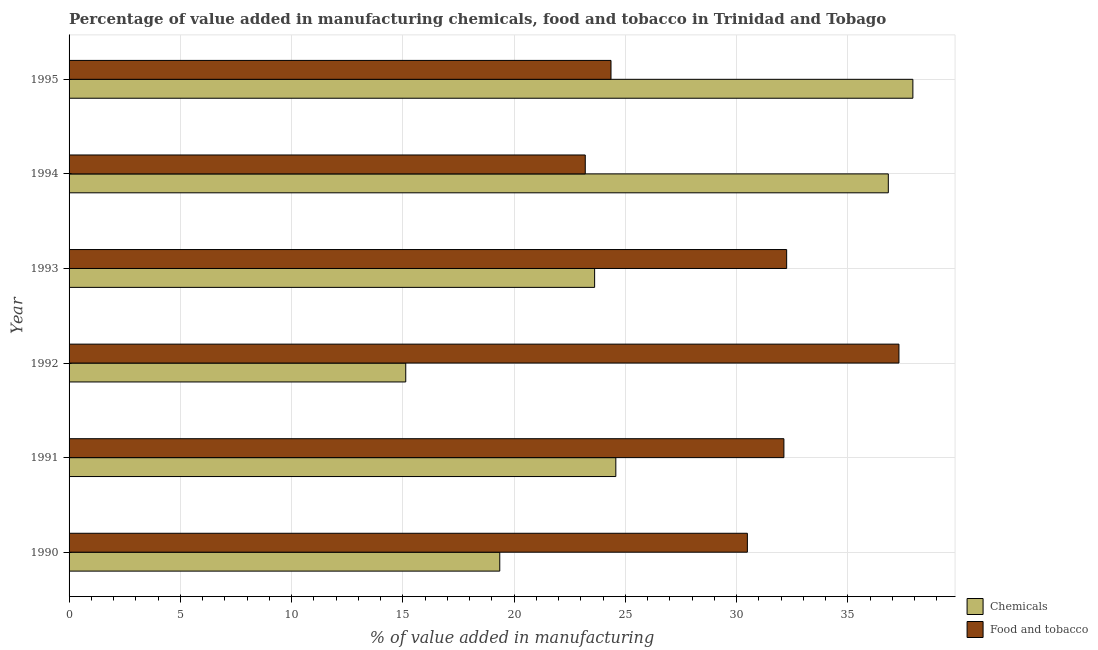Are the number of bars on each tick of the Y-axis equal?
Ensure brevity in your answer.  Yes. How many bars are there on the 2nd tick from the bottom?
Offer a terse response. 2. What is the label of the 4th group of bars from the top?
Your response must be concise. 1992. In how many cases, is the number of bars for a given year not equal to the number of legend labels?
Give a very brief answer. 0. What is the value added by  manufacturing chemicals in 1995?
Ensure brevity in your answer.  37.92. Across all years, what is the maximum value added by manufacturing food and tobacco?
Your response must be concise. 37.3. Across all years, what is the minimum value added by  manufacturing chemicals?
Your response must be concise. 15.13. In which year was the value added by  manufacturing chemicals maximum?
Offer a very short reply. 1995. In which year was the value added by  manufacturing chemicals minimum?
Provide a short and direct response. 1992. What is the total value added by  manufacturing chemicals in the graph?
Give a very brief answer. 157.42. What is the difference between the value added by  manufacturing chemicals in 1993 and that in 1994?
Offer a terse response. -13.2. What is the difference between the value added by  manufacturing chemicals in 1992 and the value added by manufacturing food and tobacco in 1995?
Your answer should be very brief. -9.22. What is the average value added by manufacturing food and tobacco per year?
Offer a terse response. 29.95. In the year 1992, what is the difference between the value added by manufacturing food and tobacco and value added by  manufacturing chemicals?
Keep it short and to the point. 22.16. What is the ratio of the value added by manufacturing food and tobacco in 1991 to that in 1992?
Provide a short and direct response. 0.86. What is the difference between the highest and the second highest value added by  manufacturing chemicals?
Offer a terse response. 1.1. In how many years, is the value added by manufacturing food and tobacco greater than the average value added by manufacturing food and tobacco taken over all years?
Your response must be concise. 4. Is the sum of the value added by  manufacturing chemicals in 1990 and 1995 greater than the maximum value added by manufacturing food and tobacco across all years?
Make the answer very short. Yes. What does the 1st bar from the top in 1991 represents?
Your answer should be compact. Food and tobacco. What does the 1st bar from the bottom in 1994 represents?
Your answer should be very brief. Chemicals. How many years are there in the graph?
Make the answer very short. 6. Are the values on the major ticks of X-axis written in scientific E-notation?
Your response must be concise. No. Does the graph contain any zero values?
Ensure brevity in your answer.  No. Where does the legend appear in the graph?
Your answer should be very brief. Bottom right. What is the title of the graph?
Offer a very short reply. Percentage of value added in manufacturing chemicals, food and tobacco in Trinidad and Tobago. What is the label or title of the X-axis?
Offer a terse response. % of value added in manufacturing. What is the % of value added in manufacturing in Chemicals in 1990?
Offer a terse response. 19.36. What is the % of value added in manufacturing in Food and tobacco in 1990?
Make the answer very short. 30.48. What is the % of value added in manufacturing in Chemicals in 1991?
Offer a very short reply. 24.57. What is the % of value added in manufacturing in Food and tobacco in 1991?
Your response must be concise. 32.13. What is the % of value added in manufacturing in Chemicals in 1992?
Your answer should be very brief. 15.13. What is the % of value added in manufacturing in Food and tobacco in 1992?
Offer a very short reply. 37.3. What is the % of value added in manufacturing of Chemicals in 1993?
Offer a very short reply. 23.62. What is the % of value added in manufacturing of Food and tobacco in 1993?
Your answer should be compact. 32.25. What is the % of value added in manufacturing of Chemicals in 1994?
Ensure brevity in your answer.  36.82. What is the % of value added in manufacturing of Food and tobacco in 1994?
Offer a terse response. 23.2. What is the % of value added in manufacturing in Chemicals in 1995?
Provide a short and direct response. 37.92. What is the % of value added in manufacturing in Food and tobacco in 1995?
Keep it short and to the point. 24.35. Across all years, what is the maximum % of value added in manufacturing of Chemicals?
Keep it short and to the point. 37.92. Across all years, what is the maximum % of value added in manufacturing of Food and tobacco?
Provide a succinct answer. 37.3. Across all years, what is the minimum % of value added in manufacturing of Chemicals?
Provide a succinct answer. 15.13. Across all years, what is the minimum % of value added in manufacturing in Food and tobacco?
Provide a short and direct response. 23.2. What is the total % of value added in manufacturing in Chemicals in the graph?
Offer a very short reply. 157.42. What is the total % of value added in manufacturing in Food and tobacco in the graph?
Ensure brevity in your answer.  179.71. What is the difference between the % of value added in manufacturing in Chemicals in 1990 and that in 1991?
Ensure brevity in your answer.  -5.22. What is the difference between the % of value added in manufacturing in Food and tobacco in 1990 and that in 1991?
Keep it short and to the point. -1.64. What is the difference between the % of value added in manufacturing in Chemicals in 1990 and that in 1992?
Your answer should be very brief. 4.23. What is the difference between the % of value added in manufacturing in Food and tobacco in 1990 and that in 1992?
Your answer should be very brief. -6.81. What is the difference between the % of value added in manufacturing in Chemicals in 1990 and that in 1993?
Provide a short and direct response. -4.26. What is the difference between the % of value added in manufacturing of Food and tobacco in 1990 and that in 1993?
Your answer should be very brief. -1.77. What is the difference between the % of value added in manufacturing of Chemicals in 1990 and that in 1994?
Your answer should be very brief. -17.46. What is the difference between the % of value added in manufacturing in Food and tobacco in 1990 and that in 1994?
Keep it short and to the point. 7.29. What is the difference between the % of value added in manufacturing of Chemicals in 1990 and that in 1995?
Ensure brevity in your answer.  -18.57. What is the difference between the % of value added in manufacturing of Food and tobacco in 1990 and that in 1995?
Provide a short and direct response. 6.13. What is the difference between the % of value added in manufacturing in Chemicals in 1991 and that in 1992?
Offer a very short reply. 9.44. What is the difference between the % of value added in manufacturing of Food and tobacco in 1991 and that in 1992?
Offer a terse response. -5.17. What is the difference between the % of value added in manufacturing of Chemicals in 1991 and that in 1993?
Ensure brevity in your answer.  0.95. What is the difference between the % of value added in manufacturing in Food and tobacco in 1991 and that in 1993?
Offer a terse response. -0.12. What is the difference between the % of value added in manufacturing in Chemicals in 1991 and that in 1994?
Provide a short and direct response. -12.25. What is the difference between the % of value added in manufacturing of Food and tobacco in 1991 and that in 1994?
Your answer should be compact. 8.93. What is the difference between the % of value added in manufacturing of Chemicals in 1991 and that in 1995?
Make the answer very short. -13.35. What is the difference between the % of value added in manufacturing in Food and tobacco in 1991 and that in 1995?
Offer a very short reply. 7.77. What is the difference between the % of value added in manufacturing in Chemicals in 1992 and that in 1993?
Give a very brief answer. -8.49. What is the difference between the % of value added in manufacturing in Food and tobacco in 1992 and that in 1993?
Give a very brief answer. 5.05. What is the difference between the % of value added in manufacturing in Chemicals in 1992 and that in 1994?
Ensure brevity in your answer.  -21.69. What is the difference between the % of value added in manufacturing in Food and tobacco in 1992 and that in 1994?
Offer a very short reply. 14.1. What is the difference between the % of value added in manufacturing of Chemicals in 1992 and that in 1995?
Provide a short and direct response. -22.79. What is the difference between the % of value added in manufacturing in Food and tobacco in 1992 and that in 1995?
Provide a short and direct response. 12.94. What is the difference between the % of value added in manufacturing of Chemicals in 1993 and that in 1994?
Provide a short and direct response. -13.2. What is the difference between the % of value added in manufacturing of Food and tobacco in 1993 and that in 1994?
Your answer should be very brief. 9.05. What is the difference between the % of value added in manufacturing in Chemicals in 1993 and that in 1995?
Your response must be concise. -14.3. What is the difference between the % of value added in manufacturing of Food and tobacco in 1993 and that in 1995?
Make the answer very short. 7.89. What is the difference between the % of value added in manufacturing of Chemicals in 1994 and that in 1995?
Give a very brief answer. -1.1. What is the difference between the % of value added in manufacturing in Food and tobacco in 1994 and that in 1995?
Your response must be concise. -1.16. What is the difference between the % of value added in manufacturing in Chemicals in 1990 and the % of value added in manufacturing in Food and tobacco in 1991?
Your response must be concise. -12.77. What is the difference between the % of value added in manufacturing in Chemicals in 1990 and the % of value added in manufacturing in Food and tobacco in 1992?
Provide a succinct answer. -17.94. What is the difference between the % of value added in manufacturing in Chemicals in 1990 and the % of value added in manufacturing in Food and tobacco in 1993?
Your answer should be compact. -12.89. What is the difference between the % of value added in manufacturing of Chemicals in 1990 and the % of value added in manufacturing of Food and tobacco in 1994?
Give a very brief answer. -3.84. What is the difference between the % of value added in manufacturing of Chemicals in 1990 and the % of value added in manufacturing of Food and tobacco in 1995?
Your answer should be very brief. -5. What is the difference between the % of value added in manufacturing of Chemicals in 1991 and the % of value added in manufacturing of Food and tobacco in 1992?
Offer a very short reply. -12.72. What is the difference between the % of value added in manufacturing of Chemicals in 1991 and the % of value added in manufacturing of Food and tobacco in 1993?
Ensure brevity in your answer.  -7.68. What is the difference between the % of value added in manufacturing in Chemicals in 1991 and the % of value added in manufacturing in Food and tobacco in 1994?
Your response must be concise. 1.37. What is the difference between the % of value added in manufacturing in Chemicals in 1991 and the % of value added in manufacturing in Food and tobacco in 1995?
Your answer should be compact. 0.22. What is the difference between the % of value added in manufacturing in Chemicals in 1992 and the % of value added in manufacturing in Food and tobacco in 1993?
Your answer should be compact. -17.12. What is the difference between the % of value added in manufacturing in Chemicals in 1992 and the % of value added in manufacturing in Food and tobacco in 1994?
Give a very brief answer. -8.07. What is the difference between the % of value added in manufacturing in Chemicals in 1992 and the % of value added in manufacturing in Food and tobacco in 1995?
Provide a succinct answer. -9.22. What is the difference between the % of value added in manufacturing in Chemicals in 1993 and the % of value added in manufacturing in Food and tobacco in 1994?
Your answer should be compact. 0.42. What is the difference between the % of value added in manufacturing of Chemicals in 1993 and the % of value added in manufacturing of Food and tobacco in 1995?
Make the answer very short. -0.74. What is the difference between the % of value added in manufacturing of Chemicals in 1994 and the % of value added in manufacturing of Food and tobacco in 1995?
Offer a terse response. 12.46. What is the average % of value added in manufacturing in Chemicals per year?
Your answer should be compact. 26.24. What is the average % of value added in manufacturing of Food and tobacco per year?
Your response must be concise. 29.95. In the year 1990, what is the difference between the % of value added in manufacturing of Chemicals and % of value added in manufacturing of Food and tobacco?
Keep it short and to the point. -11.13. In the year 1991, what is the difference between the % of value added in manufacturing of Chemicals and % of value added in manufacturing of Food and tobacco?
Provide a short and direct response. -7.55. In the year 1992, what is the difference between the % of value added in manufacturing of Chemicals and % of value added in manufacturing of Food and tobacco?
Keep it short and to the point. -22.17. In the year 1993, what is the difference between the % of value added in manufacturing in Chemicals and % of value added in manufacturing in Food and tobacco?
Provide a short and direct response. -8.63. In the year 1994, what is the difference between the % of value added in manufacturing of Chemicals and % of value added in manufacturing of Food and tobacco?
Your answer should be compact. 13.62. In the year 1995, what is the difference between the % of value added in manufacturing of Chemicals and % of value added in manufacturing of Food and tobacco?
Ensure brevity in your answer.  13.57. What is the ratio of the % of value added in manufacturing of Chemicals in 1990 to that in 1991?
Your answer should be compact. 0.79. What is the ratio of the % of value added in manufacturing in Food and tobacco in 1990 to that in 1991?
Your response must be concise. 0.95. What is the ratio of the % of value added in manufacturing in Chemicals in 1990 to that in 1992?
Offer a terse response. 1.28. What is the ratio of the % of value added in manufacturing of Food and tobacco in 1990 to that in 1992?
Ensure brevity in your answer.  0.82. What is the ratio of the % of value added in manufacturing of Chemicals in 1990 to that in 1993?
Give a very brief answer. 0.82. What is the ratio of the % of value added in manufacturing of Food and tobacco in 1990 to that in 1993?
Provide a succinct answer. 0.95. What is the ratio of the % of value added in manufacturing of Chemicals in 1990 to that in 1994?
Provide a short and direct response. 0.53. What is the ratio of the % of value added in manufacturing in Food and tobacco in 1990 to that in 1994?
Make the answer very short. 1.31. What is the ratio of the % of value added in manufacturing of Chemicals in 1990 to that in 1995?
Ensure brevity in your answer.  0.51. What is the ratio of the % of value added in manufacturing in Food and tobacco in 1990 to that in 1995?
Your answer should be very brief. 1.25. What is the ratio of the % of value added in manufacturing of Chemicals in 1991 to that in 1992?
Make the answer very short. 1.62. What is the ratio of the % of value added in manufacturing in Food and tobacco in 1991 to that in 1992?
Ensure brevity in your answer.  0.86. What is the ratio of the % of value added in manufacturing of Chemicals in 1991 to that in 1993?
Ensure brevity in your answer.  1.04. What is the ratio of the % of value added in manufacturing of Chemicals in 1991 to that in 1994?
Your response must be concise. 0.67. What is the ratio of the % of value added in manufacturing of Food and tobacco in 1991 to that in 1994?
Your response must be concise. 1.38. What is the ratio of the % of value added in manufacturing of Chemicals in 1991 to that in 1995?
Make the answer very short. 0.65. What is the ratio of the % of value added in manufacturing of Food and tobacco in 1991 to that in 1995?
Your answer should be very brief. 1.32. What is the ratio of the % of value added in manufacturing in Chemicals in 1992 to that in 1993?
Provide a succinct answer. 0.64. What is the ratio of the % of value added in manufacturing of Food and tobacco in 1992 to that in 1993?
Your answer should be very brief. 1.16. What is the ratio of the % of value added in manufacturing in Chemicals in 1992 to that in 1994?
Make the answer very short. 0.41. What is the ratio of the % of value added in manufacturing in Food and tobacco in 1992 to that in 1994?
Provide a short and direct response. 1.61. What is the ratio of the % of value added in manufacturing of Chemicals in 1992 to that in 1995?
Your response must be concise. 0.4. What is the ratio of the % of value added in manufacturing in Food and tobacco in 1992 to that in 1995?
Keep it short and to the point. 1.53. What is the ratio of the % of value added in manufacturing of Chemicals in 1993 to that in 1994?
Your answer should be very brief. 0.64. What is the ratio of the % of value added in manufacturing of Food and tobacco in 1993 to that in 1994?
Make the answer very short. 1.39. What is the ratio of the % of value added in manufacturing in Chemicals in 1993 to that in 1995?
Provide a succinct answer. 0.62. What is the ratio of the % of value added in manufacturing in Food and tobacco in 1993 to that in 1995?
Your answer should be compact. 1.32. What is the ratio of the % of value added in manufacturing in Chemicals in 1994 to that in 1995?
Keep it short and to the point. 0.97. What is the ratio of the % of value added in manufacturing in Food and tobacco in 1994 to that in 1995?
Make the answer very short. 0.95. What is the difference between the highest and the second highest % of value added in manufacturing in Chemicals?
Offer a terse response. 1.1. What is the difference between the highest and the second highest % of value added in manufacturing of Food and tobacco?
Make the answer very short. 5.05. What is the difference between the highest and the lowest % of value added in manufacturing in Chemicals?
Your response must be concise. 22.79. What is the difference between the highest and the lowest % of value added in manufacturing of Food and tobacco?
Ensure brevity in your answer.  14.1. 